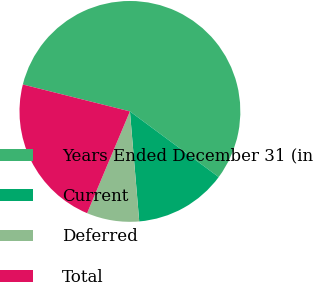Convert chart to OTSL. <chart><loc_0><loc_0><loc_500><loc_500><pie_chart><fcel>Years Ended December 31 (in<fcel>Current<fcel>Deferred<fcel>Total<nl><fcel>56.22%<fcel>13.52%<fcel>7.68%<fcel>22.58%<nl></chart> 